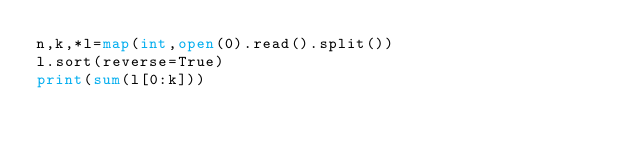<code> <loc_0><loc_0><loc_500><loc_500><_Python_>n,k,*l=map(int,open(0).read().split())
l.sort(reverse=True)
print(sum(l[0:k]))</code> 